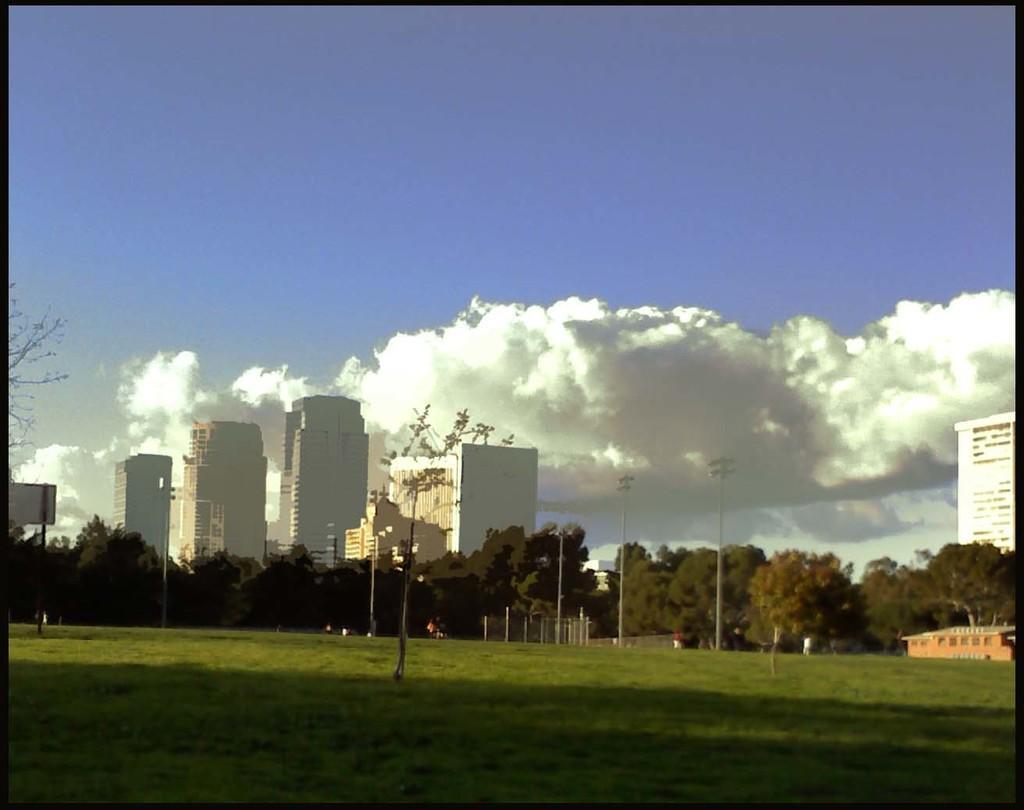In one or two sentences, can you explain what this image depicts? In this image we can see grass, few trees, buildings, poles, a pole with board and the sky with clouds in the background. 